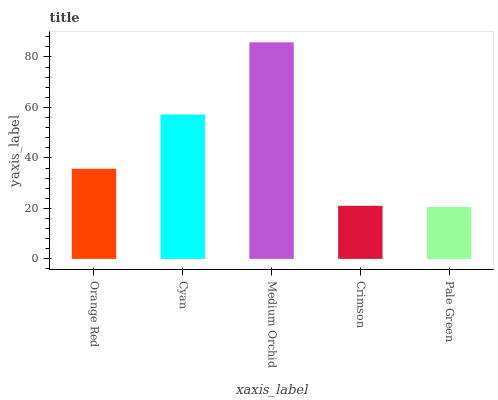Is Cyan the minimum?
Answer yes or no. No. Is Cyan the maximum?
Answer yes or no. No. Is Cyan greater than Orange Red?
Answer yes or no. Yes. Is Orange Red less than Cyan?
Answer yes or no. Yes. Is Orange Red greater than Cyan?
Answer yes or no. No. Is Cyan less than Orange Red?
Answer yes or no. No. Is Orange Red the high median?
Answer yes or no. Yes. Is Orange Red the low median?
Answer yes or no. Yes. Is Cyan the high median?
Answer yes or no. No. Is Cyan the low median?
Answer yes or no. No. 